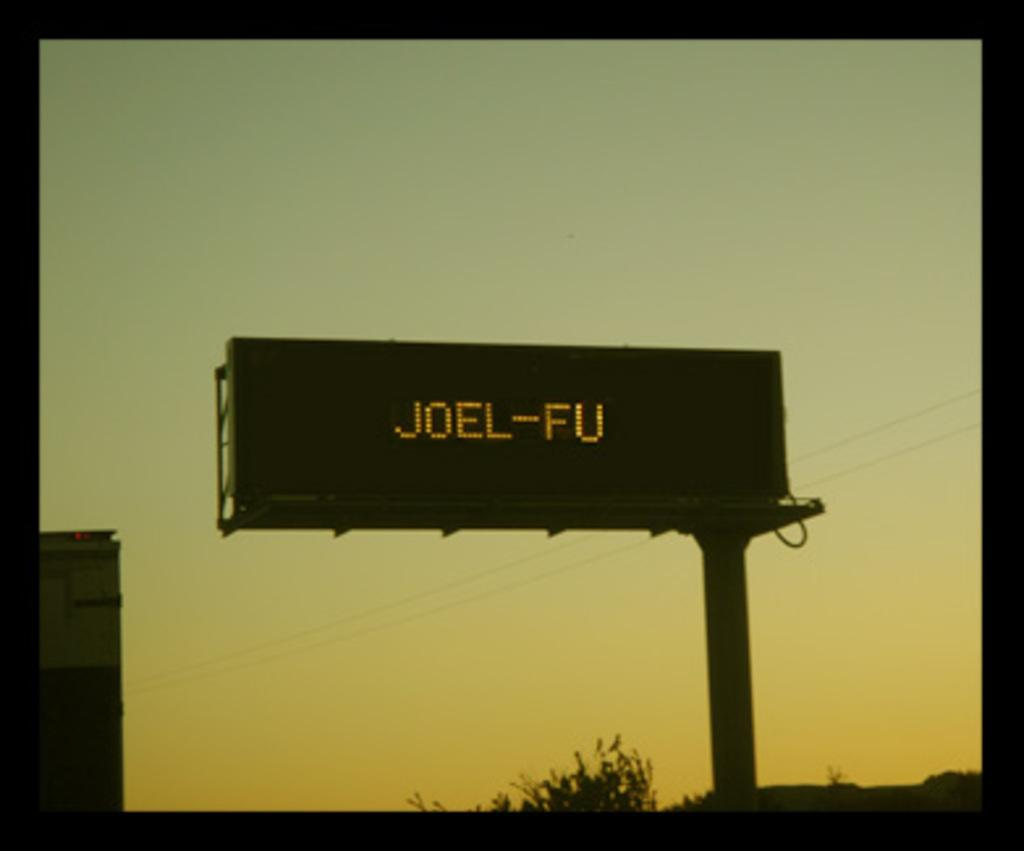<image>
Share a concise interpretation of the image provided. a billboard that says 'joel-fu' on it outside 